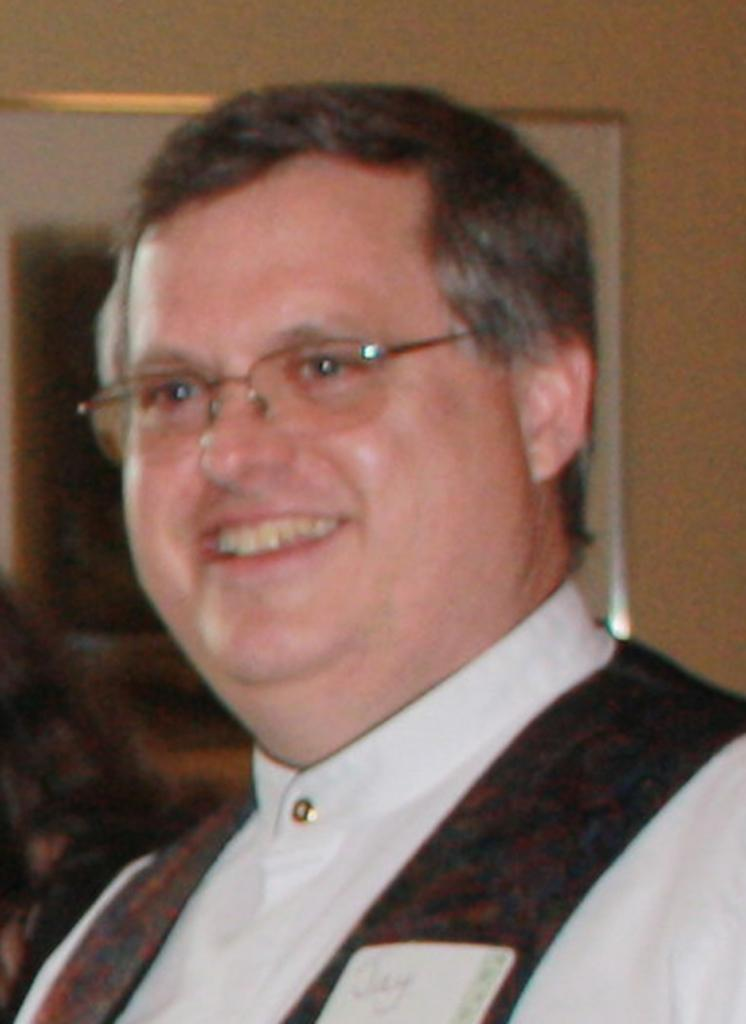Where was the image taken? The image is taken indoors. What can be seen in the background of the image? There is a wall with a picture frame in the background. Who is the main subject in the image? There is a man in the middle of the image. What is the man's facial expression in the image? The man has a smiling face. What arithmetic problem is the man solving in the image? There is no arithmetic problem visible in the image. What act is the man performing in the image? The image does not depict a specific act; it simply shows a man with a smiling face. 